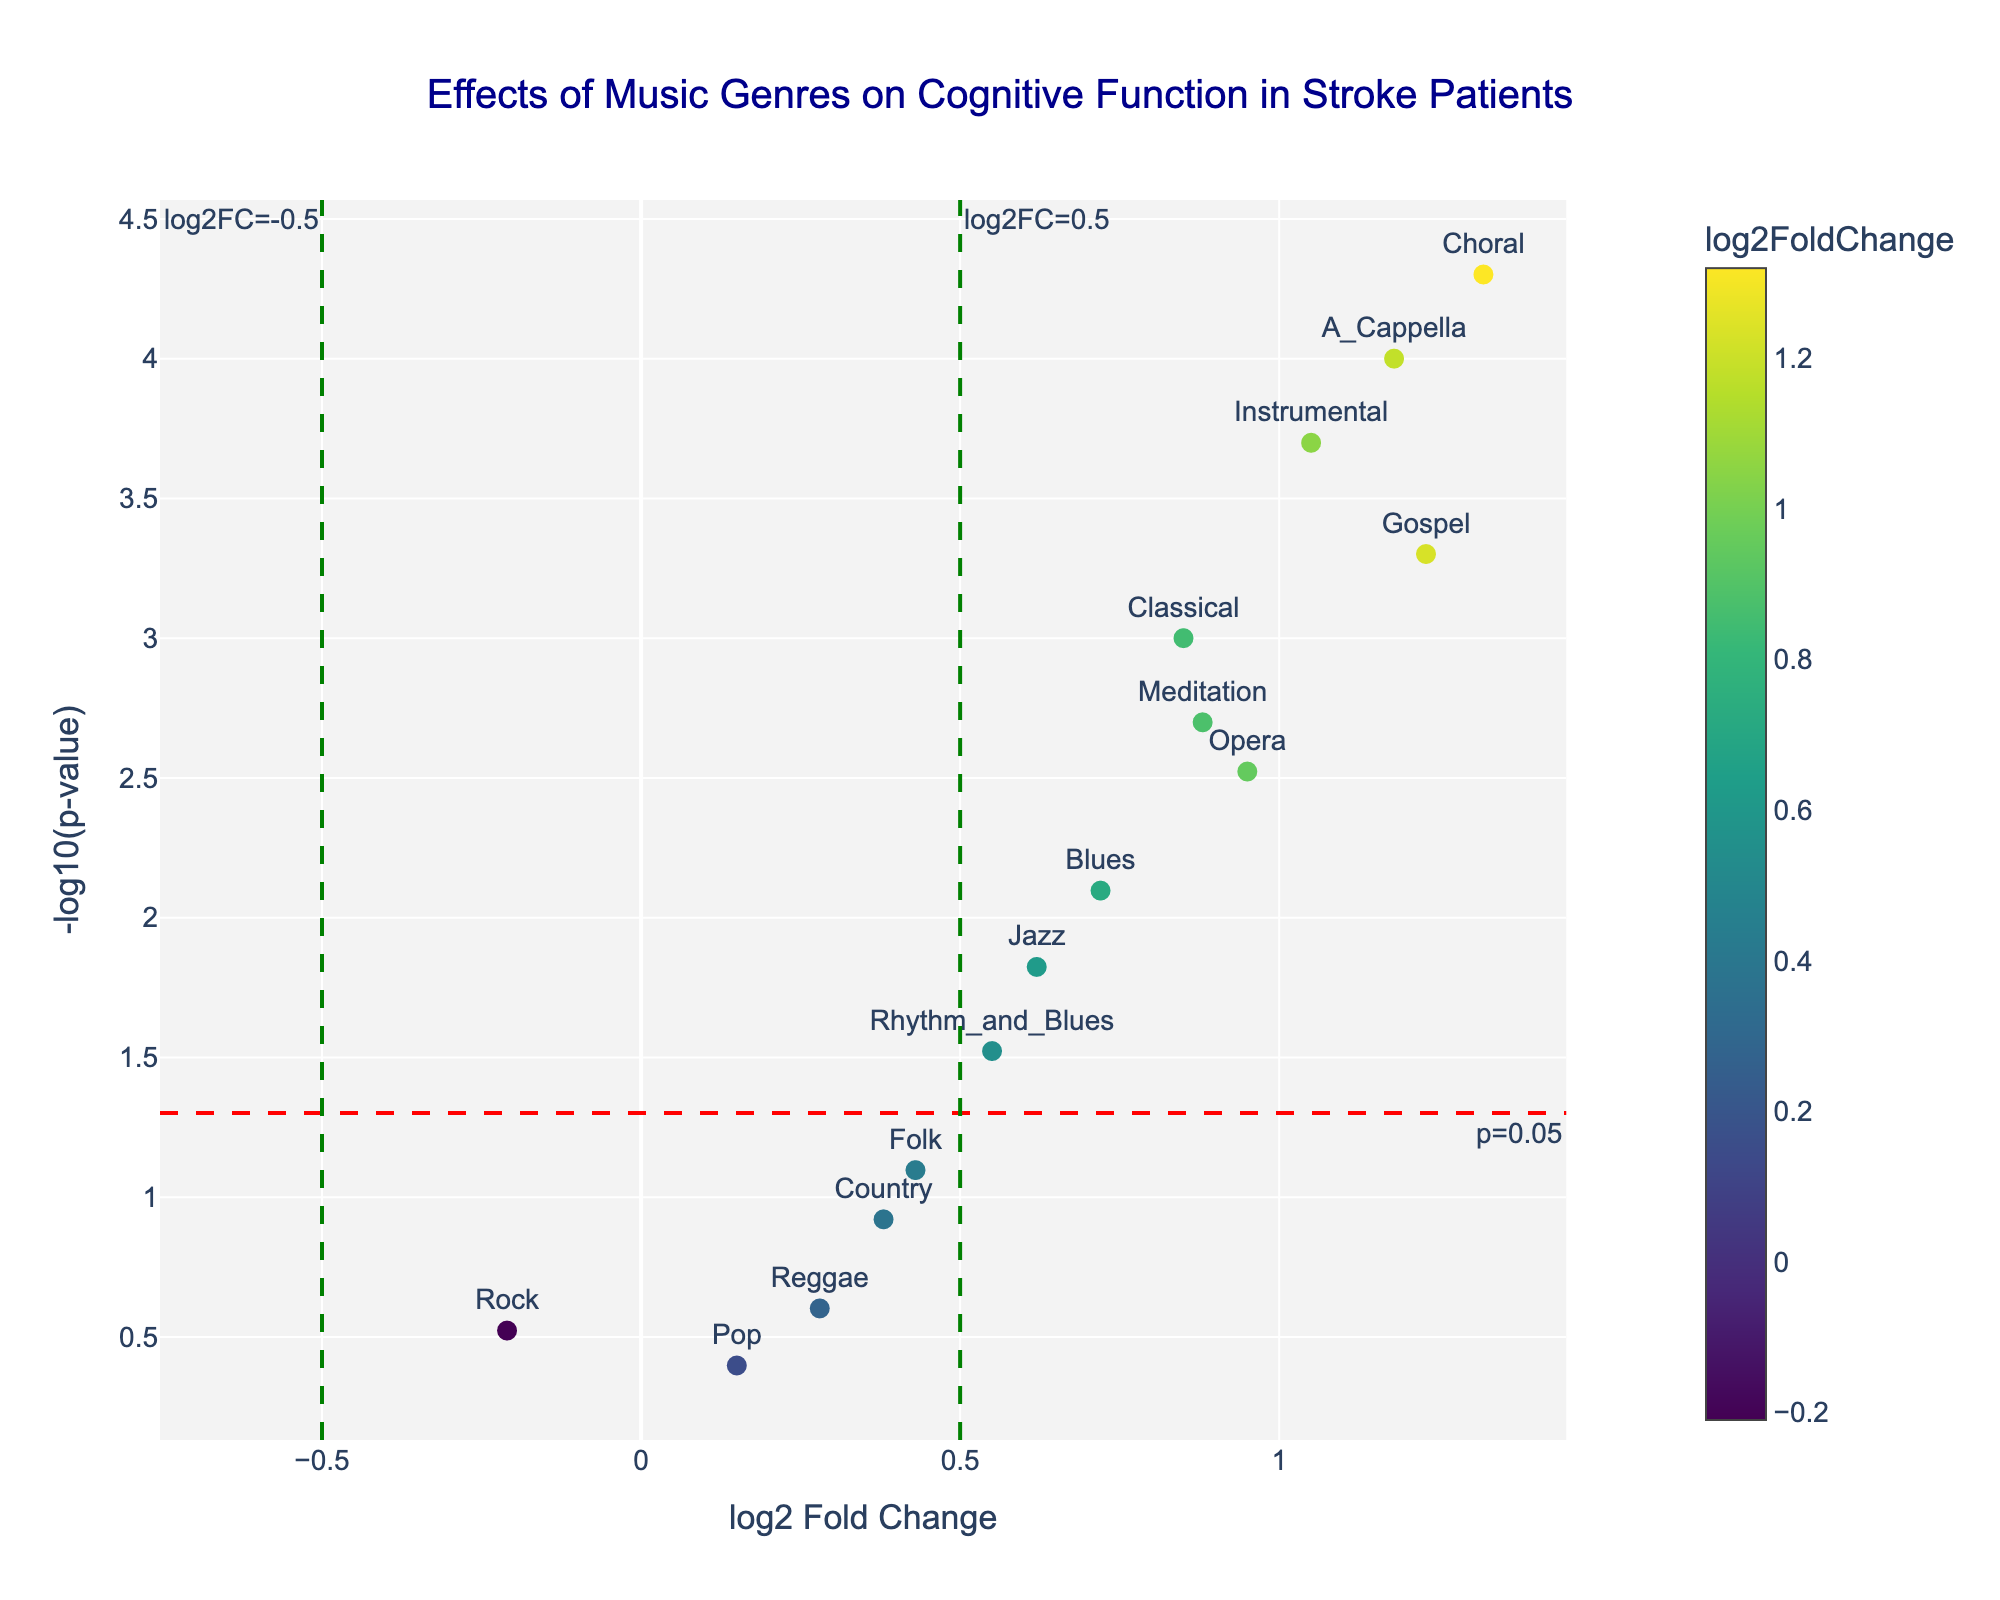What is the title of the plot? The title is located at the top center of the plot.
Answer: Effects of Music Genres on Cognitive Function in Stroke Patients How many genres show a significant positive effect on cognitive function with a log2 fold change greater than 0.5? From the plot, we observe which data points lie above the green vertical line at log2FC greater than 0.5 and above the red horizontal line indicating p-value < 0.05.
Answer: 7 Which music genre has the highest log2 fold change value? By identifying the point farthest to the right on the x-axis, we determine the genre with the highest log2FoldChange.
Answer: Choral What is the p-value threshold line shown in the plot? The red dashed horizontal line signifies the threshold, and its annotation indicates the p-value it represents.
Answer: 0.05 How many genres have a p-value less than 0.01? By observing the number of points that are above -log10(0.01) on the y-axis, we find the genres with p-values less than 0.01.
Answer: 5 Which genre shows the least significant improvement in cognitive function? The genre with the largest value on the y-axis is considered the least significant. From the plot, we locate the point with the lowest -log10(p-value).
Answer: Pop Which genre has a log2 fold change closest to zero but still shows a significant p-value? We locate which points are closest to the vertical line at log2FC = 0 that are also above the red dashed line for p < 0.05.
Answer: Rhythm_and_Blues What is the log2 fold change for Instrumental music? By finding the "Instrumental" text label on the plot and noting its position relative to the x-axis, we get its log2 fold change.
Answer: 1.05 Which genres have a negative log2 fold change? Points located left of the vertical line at log2FC = 0 represent negative values. Identify the genres associated with these points.
Answer: Rock 